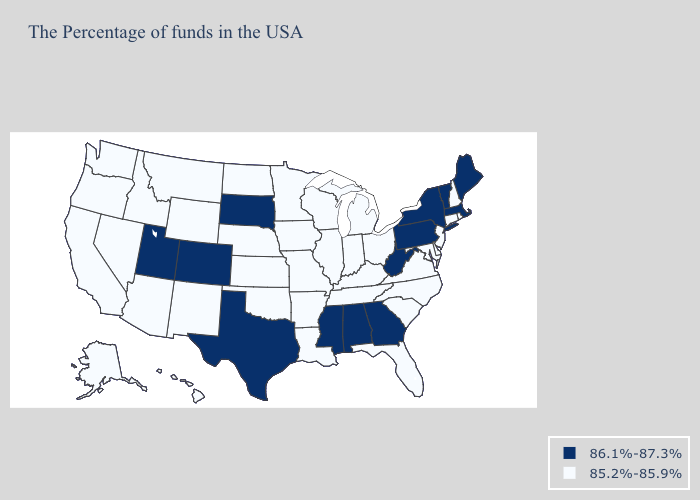Is the legend a continuous bar?
Keep it brief. No. Does the first symbol in the legend represent the smallest category?
Keep it brief. No. Name the states that have a value in the range 85.2%-85.9%?
Concise answer only. Rhode Island, New Hampshire, Connecticut, New Jersey, Delaware, Maryland, Virginia, North Carolina, South Carolina, Ohio, Florida, Michigan, Kentucky, Indiana, Tennessee, Wisconsin, Illinois, Louisiana, Missouri, Arkansas, Minnesota, Iowa, Kansas, Nebraska, Oklahoma, North Dakota, Wyoming, New Mexico, Montana, Arizona, Idaho, Nevada, California, Washington, Oregon, Alaska, Hawaii. Does Vermont have the lowest value in the USA?
Answer briefly. No. Name the states that have a value in the range 85.2%-85.9%?
Be succinct. Rhode Island, New Hampshire, Connecticut, New Jersey, Delaware, Maryland, Virginia, North Carolina, South Carolina, Ohio, Florida, Michigan, Kentucky, Indiana, Tennessee, Wisconsin, Illinois, Louisiana, Missouri, Arkansas, Minnesota, Iowa, Kansas, Nebraska, Oklahoma, North Dakota, Wyoming, New Mexico, Montana, Arizona, Idaho, Nevada, California, Washington, Oregon, Alaska, Hawaii. Does Montana have the same value as Arizona?
Quick response, please. Yes. What is the value of Tennessee?
Give a very brief answer. 85.2%-85.9%. What is the highest value in the USA?
Be succinct. 86.1%-87.3%. Name the states that have a value in the range 85.2%-85.9%?
Concise answer only. Rhode Island, New Hampshire, Connecticut, New Jersey, Delaware, Maryland, Virginia, North Carolina, South Carolina, Ohio, Florida, Michigan, Kentucky, Indiana, Tennessee, Wisconsin, Illinois, Louisiana, Missouri, Arkansas, Minnesota, Iowa, Kansas, Nebraska, Oklahoma, North Dakota, Wyoming, New Mexico, Montana, Arizona, Idaho, Nevada, California, Washington, Oregon, Alaska, Hawaii. Among the states that border Utah , does Idaho have the lowest value?
Concise answer only. Yes. What is the highest value in states that border Virginia?
Answer briefly. 86.1%-87.3%. Does Maine have the highest value in the Northeast?
Short answer required. Yes. What is the value of Idaho?
Give a very brief answer. 85.2%-85.9%. Does New York have the lowest value in the Northeast?
Give a very brief answer. No. Among the states that border Louisiana , does Mississippi have the highest value?
Concise answer only. Yes. 